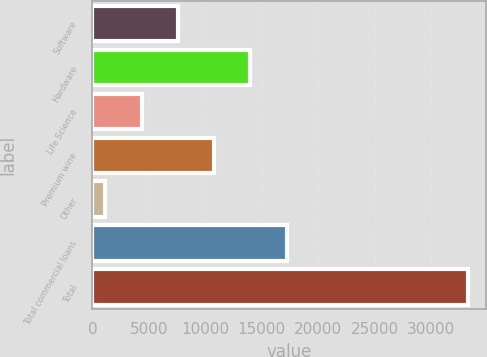Convert chart. <chart><loc_0><loc_0><loc_500><loc_500><bar_chart><fcel>Software<fcel>Hardware<fcel>Life Science<fcel>Premium wine<fcel>Other<fcel>Total commercial loans<fcel>Total<nl><fcel>7573.8<fcel>13989.6<fcel>4365.9<fcel>10781.7<fcel>1158<fcel>17197.5<fcel>33237<nl></chart> 